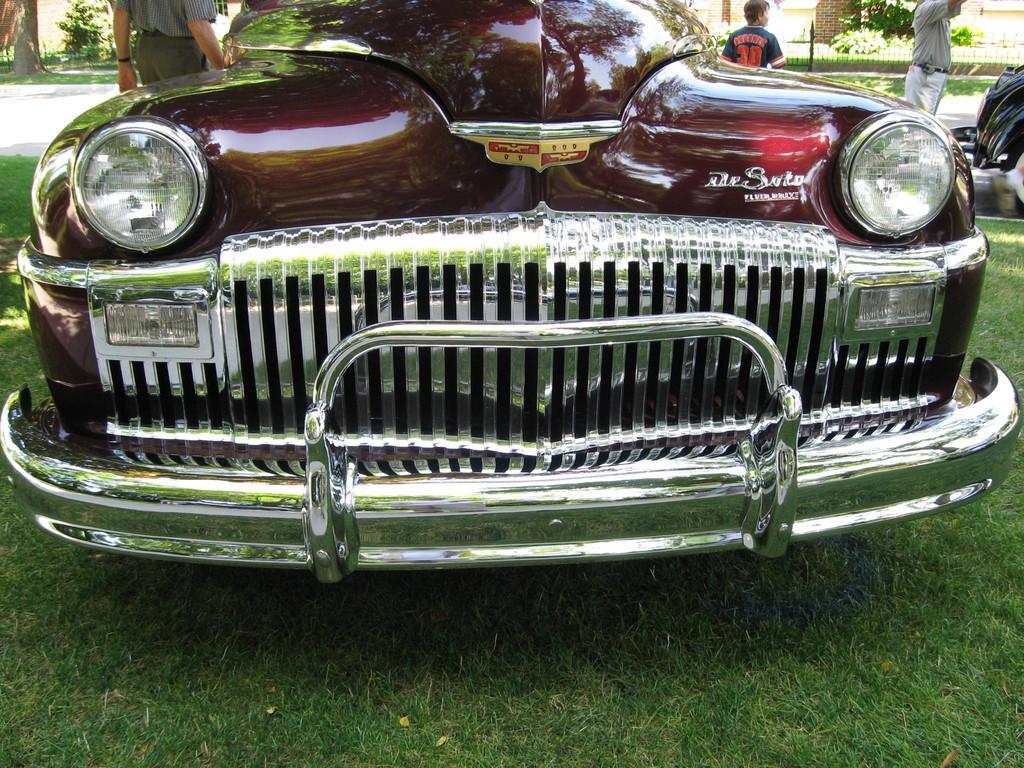In one or two sentences, can you explain what this image depicts? In this image we can see a car on the grass. In the background we can see few persons, objects, fence, plants, wall and tree trunk on the left side. 